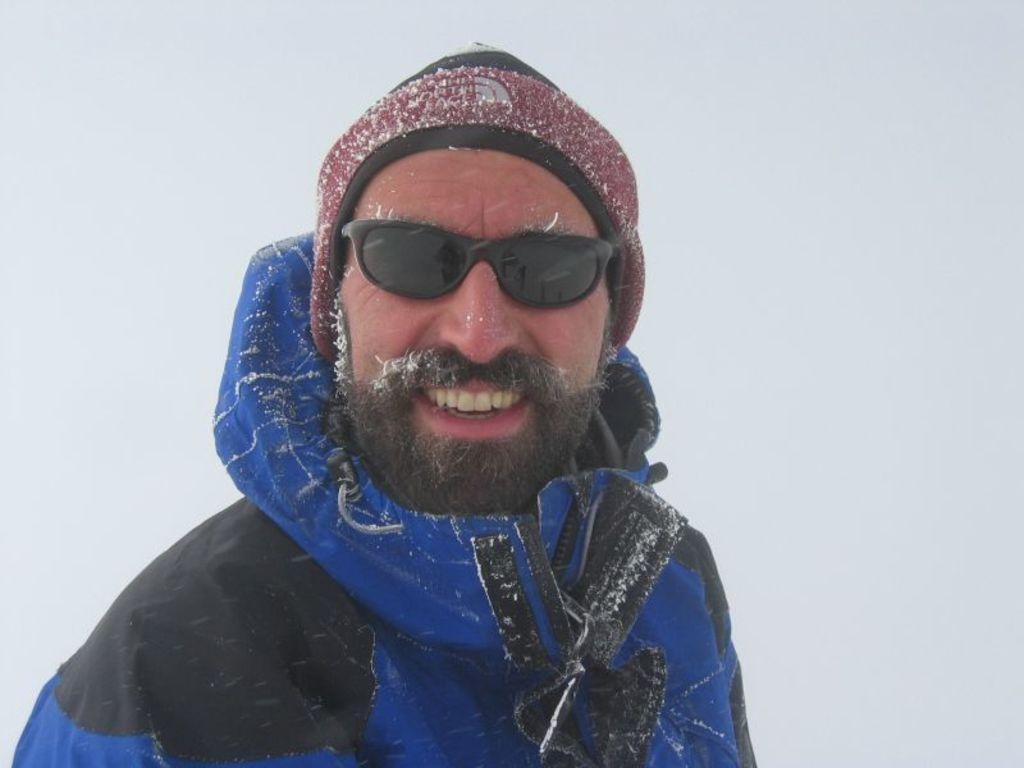What is the main subject of the image? There is a person in the image. What type of clothing is the person wearing? The person is wearing a jacket, goggles, and a cap. What is the person's facial expression in the image? The person is smiling in the image. What is the color of the background in the image? The background of the image is white. What type of club is the person holding in the image? There is no club present in the image. How many fingers can be seen wearing gloves in the image? There are no gloves or fingers visible in the image. 